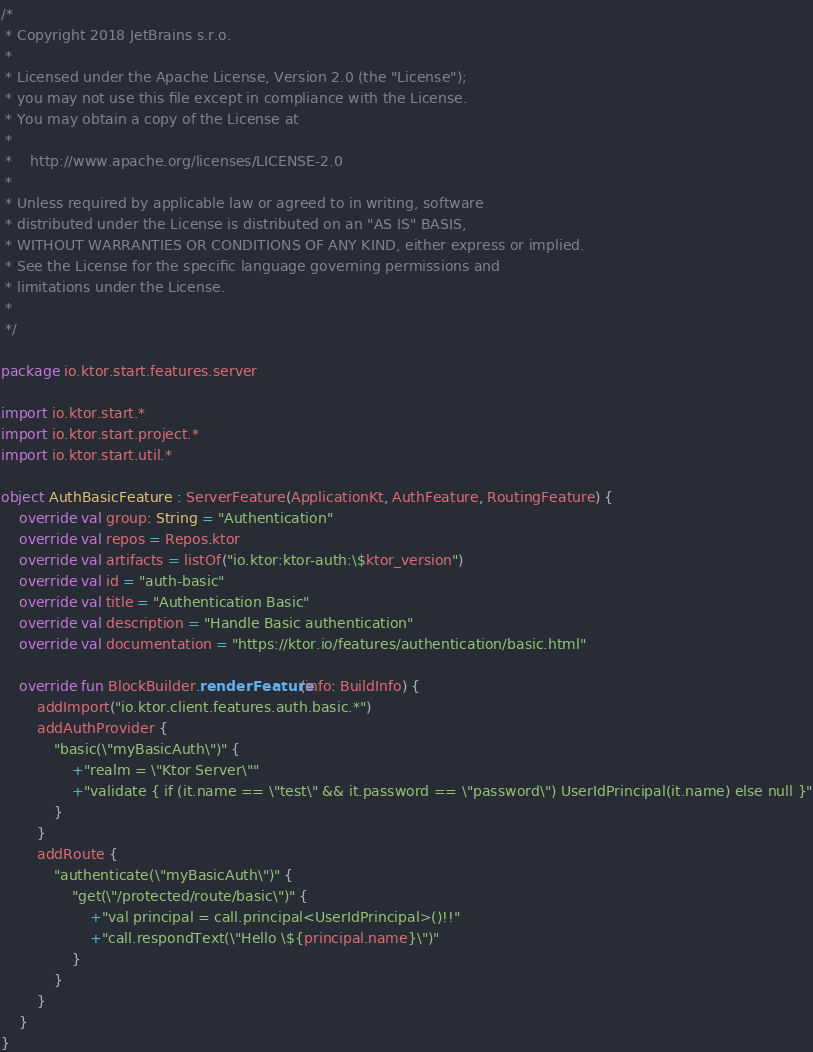<code> <loc_0><loc_0><loc_500><loc_500><_Kotlin_>/*
 * Copyright 2018 JetBrains s.r.o.
 *
 * Licensed under the Apache License, Version 2.0 (the "License");
 * you may not use this file except in compliance with the License.
 * You may obtain a copy of the License at
 *
 *    http://www.apache.org/licenses/LICENSE-2.0
 *
 * Unless required by applicable law or agreed to in writing, software
 * distributed under the License is distributed on an "AS IS" BASIS,
 * WITHOUT WARRANTIES OR CONDITIONS OF ANY KIND, either express or implied.
 * See the License for the specific language governing permissions and
 * limitations under the License.
 *
 */

package io.ktor.start.features.server

import io.ktor.start.*
import io.ktor.start.project.*
import io.ktor.start.util.*

object AuthBasicFeature : ServerFeature(ApplicationKt, AuthFeature, RoutingFeature) {
    override val group: String = "Authentication"
    override val repos = Repos.ktor
    override val artifacts = listOf("io.ktor:ktor-auth:\$ktor_version")
    override val id = "auth-basic"
    override val title = "Authentication Basic"
    override val description = "Handle Basic authentication"
    override val documentation = "https://ktor.io/features/authentication/basic.html"

    override fun BlockBuilder.renderFeature(info: BuildInfo) {
        addImport("io.ktor.client.features.auth.basic.*")
        addAuthProvider {
            "basic(\"myBasicAuth\")" {
                +"realm = \"Ktor Server\""
                +"validate { if (it.name == \"test\" && it.password == \"password\") UserIdPrincipal(it.name) else null }"
            }
        }
        addRoute {
            "authenticate(\"myBasicAuth\")" {
                "get(\"/protected/route/basic\")" {
                    +"val principal = call.principal<UserIdPrincipal>()!!"
                    +"call.respondText(\"Hello \${principal.name}\")"
                }
            }
        }
    }
}</code> 